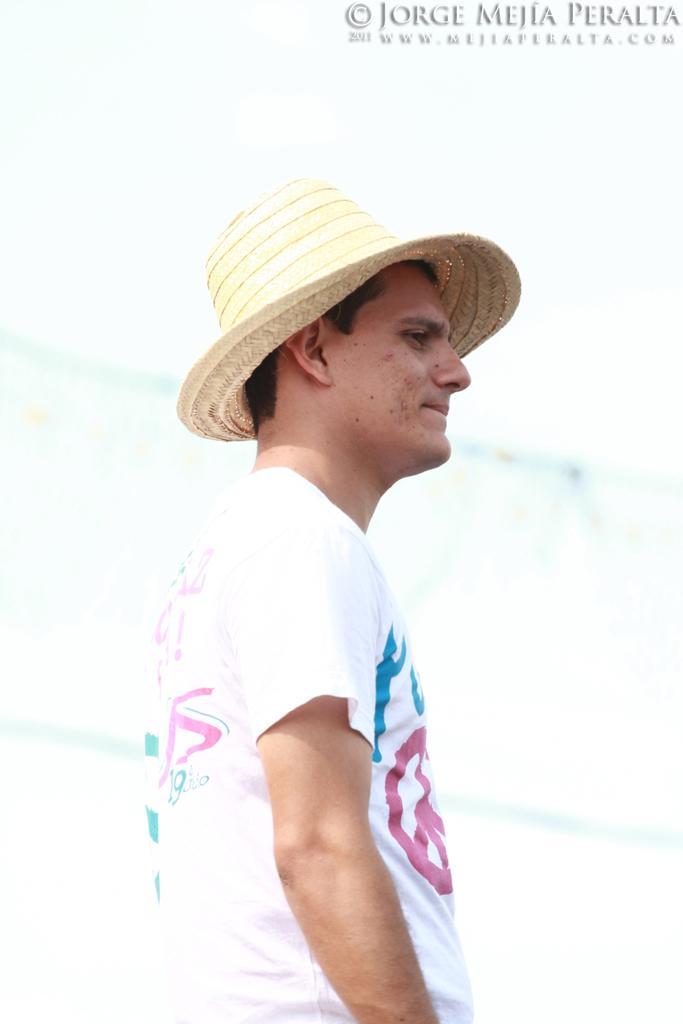In one or two sentences, can you explain what this image depicts? In this image, we can see a person wearing a hat. On the right side top corner, we can see the watermarks in the image. 